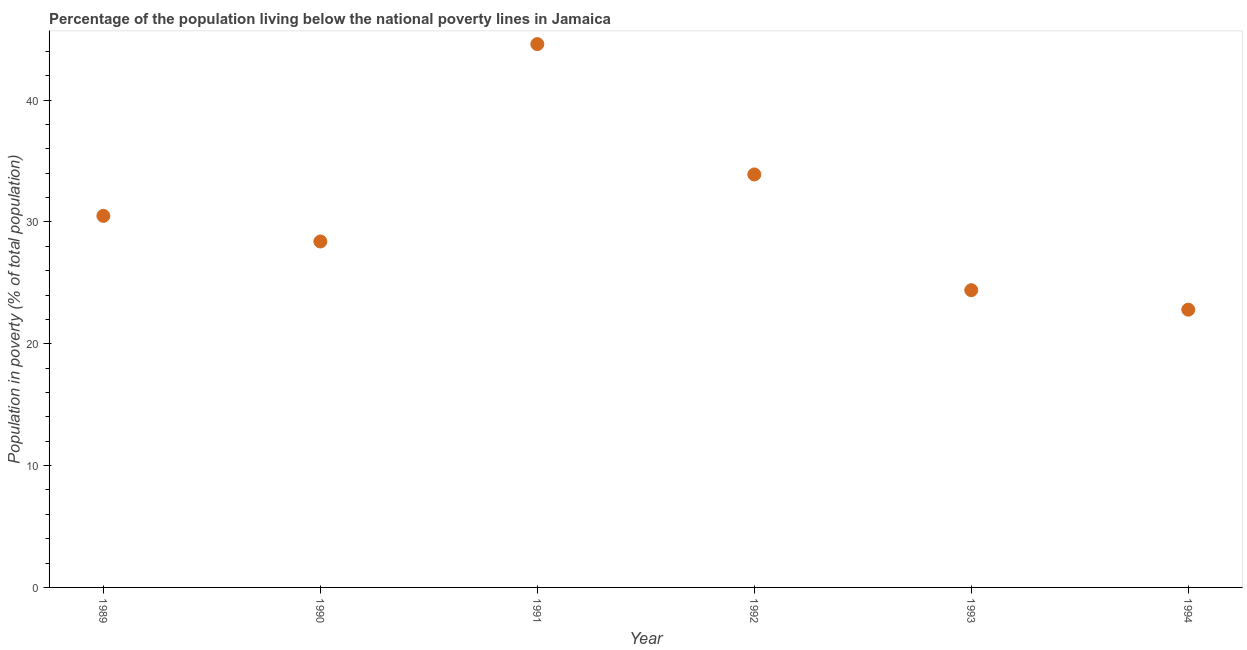What is the percentage of population living below poverty line in 1991?
Ensure brevity in your answer.  44.6. Across all years, what is the maximum percentage of population living below poverty line?
Your answer should be very brief. 44.6. Across all years, what is the minimum percentage of population living below poverty line?
Give a very brief answer. 22.8. In which year was the percentage of population living below poverty line maximum?
Give a very brief answer. 1991. In which year was the percentage of population living below poverty line minimum?
Keep it short and to the point. 1994. What is the sum of the percentage of population living below poverty line?
Provide a succinct answer. 184.6. What is the difference between the percentage of population living below poverty line in 1991 and 1992?
Your answer should be very brief. 10.7. What is the average percentage of population living below poverty line per year?
Provide a short and direct response. 30.77. What is the median percentage of population living below poverty line?
Provide a short and direct response. 29.45. In how many years, is the percentage of population living below poverty line greater than 2 %?
Offer a terse response. 6. Do a majority of the years between 1993 and 1990 (inclusive) have percentage of population living below poverty line greater than 24 %?
Offer a terse response. Yes. What is the ratio of the percentage of population living below poverty line in 1989 to that in 1994?
Your answer should be compact. 1.34. Is the percentage of population living below poverty line in 1990 less than that in 1994?
Provide a succinct answer. No. Is the difference between the percentage of population living below poverty line in 1991 and 1993 greater than the difference between any two years?
Your answer should be very brief. No. What is the difference between the highest and the second highest percentage of population living below poverty line?
Give a very brief answer. 10.7. What is the difference between the highest and the lowest percentage of population living below poverty line?
Make the answer very short. 21.8. In how many years, is the percentage of population living below poverty line greater than the average percentage of population living below poverty line taken over all years?
Provide a short and direct response. 2. Does the percentage of population living below poverty line monotonically increase over the years?
Ensure brevity in your answer.  No. How many dotlines are there?
Provide a short and direct response. 1. How many years are there in the graph?
Offer a terse response. 6. Does the graph contain any zero values?
Keep it short and to the point. No. What is the title of the graph?
Make the answer very short. Percentage of the population living below the national poverty lines in Jamaica. What is the label or title of the X-axis?
Make the answer very short. Year. What is the label or title of the Y-axis?
Provide a short and direct response. Population in poverty (% of total population). What is the Population in poverty (% of total population) in 1989?
Your answer should be very brief. 30.5. What is the Population in poverty (% of total population) in 1990?
Ensure brevity in your answer.  28.4. What is the Population in poverty (% of total population) in 1991?
Provide a succinct answer. 44.6. What is the Population in poverty (% of total population) in 1992?
Provide a short and direct response. 33.9. What is the Population in poverty (% of total population) in 1993?
Provide a succinct answer. 24.4. What is the Population in poverty (% of total population) in 1994?
Keep it short and to the point. 22.8. What is the difference between the Population in poverty (% of total population) in 1989 and 1991?
Your answer should be very brief. -14.1. What is the difference between the Population in poverty (% of total population) in 1989 and 1992?
Offer a very short reply. -3.4. What is the difference between the Population in poverty (% of total population) in 1989 and 1993?
Your response must be concise. 6.1. What is the difference between the Population in poverty (% of total population) in 1989 and 1994?
Offer a terse response. 7.7. What is the difference between the Population in poverty (% of total population) in 1990 and 1991?
Keep it short and to the point. -16.2. What is the difference between the Population in poverty (% of total population) in 1990 and 1992?
Give a very brief answer. -5.5. What is the difference between the Population in poverty (% of total population) in 1990 and 1994?
Your answer should be compact. 5.6. What is the difference between the Population in poverty (% of total population) in 1991 and 1992?
Your response must be concise. 10.7. What is the difference between the Population in poverty (% of total population) in 1991 and 1993?
Give a very brief answer. 20.2. What is the difference between the Population in poverty (% of total population) in 1991 and 1994?
Offer a terse response. 21.8. What is the ratio of the Population in poverty (% of total population) in 1989 to that in 1990?
Make the answer very short. 1.07. What is the ratio of the Population in poverty (% of total population) in 1989 to that in 1991?
Offer a terse response. 0.68. What is the ratio of the Population in poverty (% of total population) in 1989 to that in 1994?
Provide a short and direct response. 1.34. What is the ratio of the Population in poverty (% of total population) in 1990 to that in 1991?
Provide a short and direct response. 0.64. What is the ratio of the Population in poverty (% of total population) in 1990 to that in 1992?
Offer a terse response. 0.84. What is the ratio of the Population in poverty (% of total population) in 1990 to that in 1993?
Your answer should be compact. 1.16. What is the ratio of the Population in poverty (% of total population) in 1990 to that in 1994?
Provide a short and direct response. 1.25. What is the ratio of the Population in poverty (% of total population) in 1991 to that in 1992?
Make the answer very short. 1.32. What is the ratio of the Population in poverty (% of total population) in 1991 to that in 1993?
Your answer should be compact. 1.83. What is the ratio of the Population in poverty (% of total population) in 1991 to that in 1994?
Make the answer very short. 1.96. What is the ratio of the Population in poverty (% of total population) in 1992 to that in 1993?
Your answer should be very brief. 1.39. What is the ratio of the Population in poverty (% of total population) in 1992 to that in 1994?
Ensure brevity in your answer.  1.49. What is the ratio of the Population in poverty (% of total population) in 1993 to that in 1994?
Offer a terse response. 1.07. 